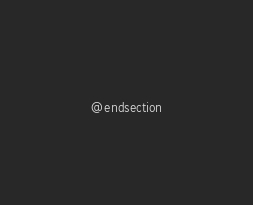<code> <loc_0><loc_0><loc_500><loc_500><_PHP_>@endsection
</code> 